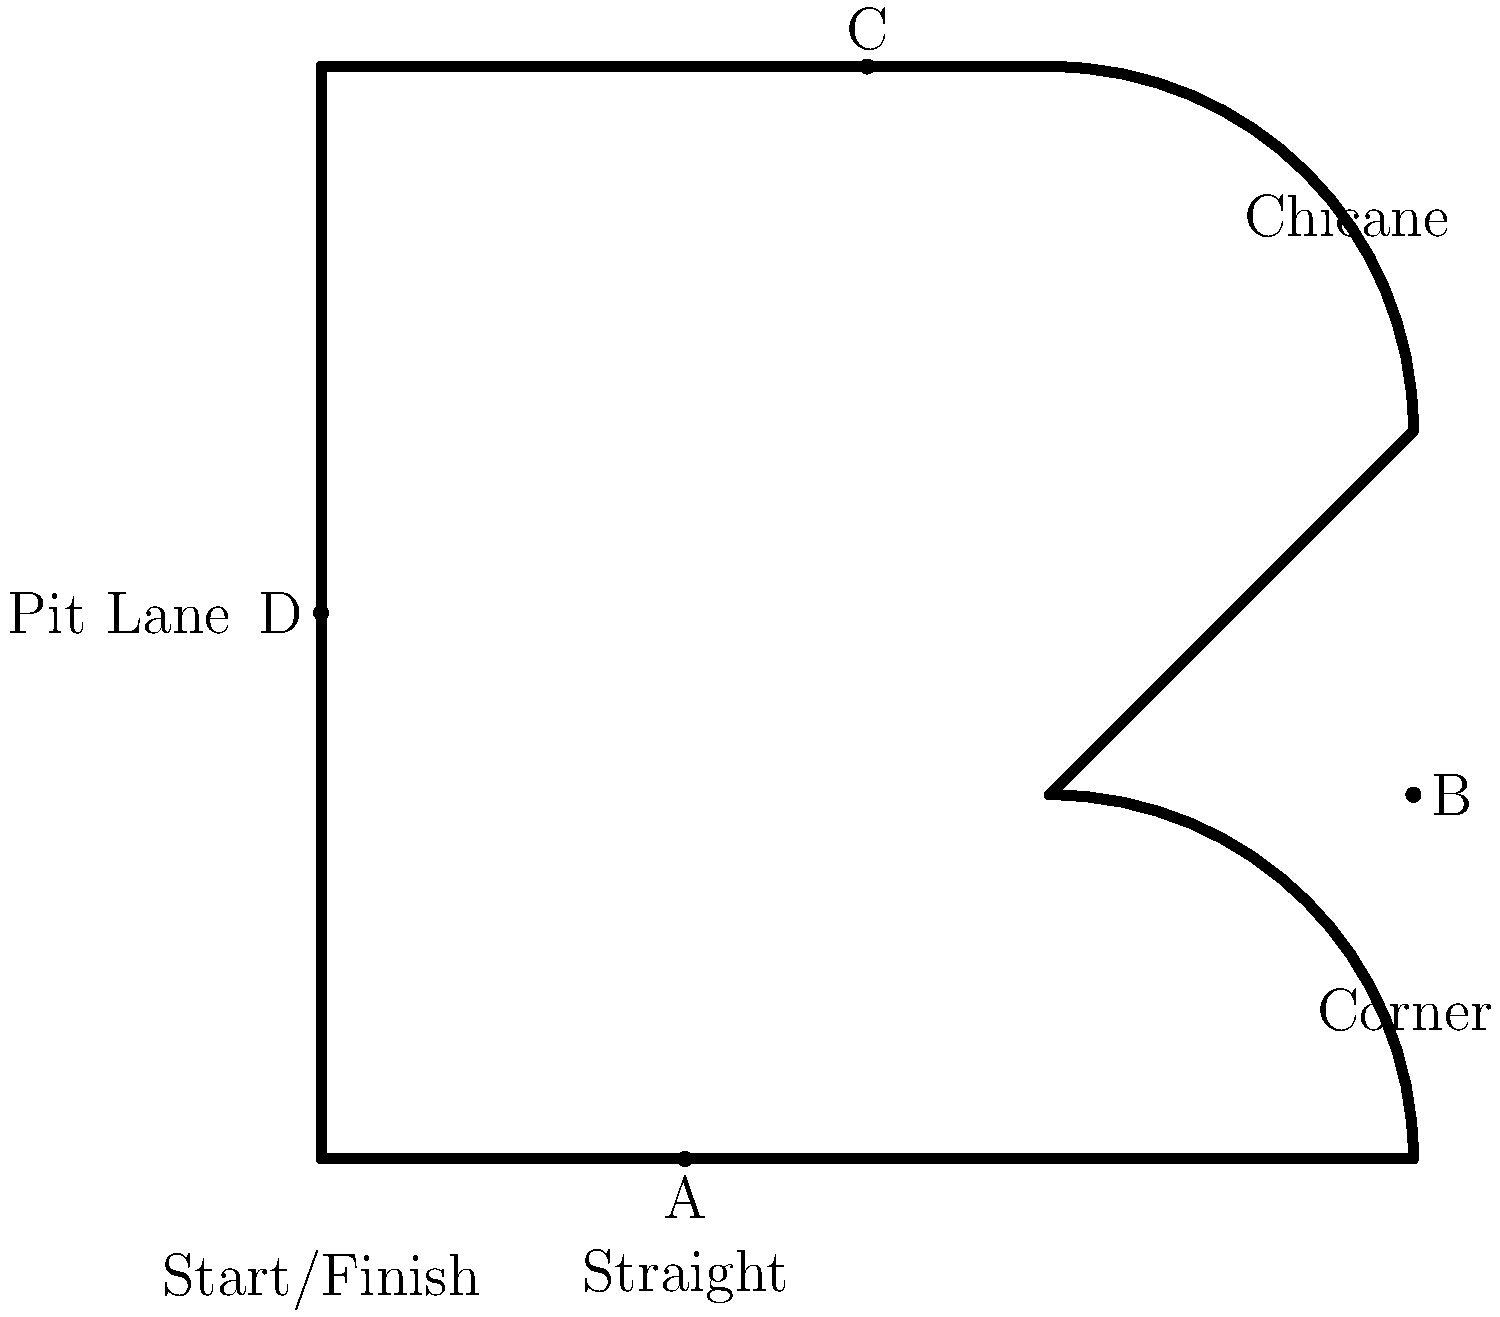Look at the race track layout above. What is the purpose of the feature labeled "B" on the track? To understand the purpose of feature B, let's break down the key elements of a race track:

1. The track layout shows various features common in motorsports circuits.

2. Feature B is located at a curved section of the track, following a straight section.

3. In racing, this type of curved section is called a corner or turn.

4. Corners serve several important purposes in racing:
   a) They test a driver's skill in controlling the car at different speeds and angles.
   b) They provide opportunities for overtaking other cars.
   c) They add variety and challenge to the track layout.

5. Corners like B require drivers to:
   a) Brake before entering the turn
   b) Choose the optimal racing line through the corner
   c) Accelerate out of the corner onto the next straight section

6. Mastering corners is crucial for achieving fast lap times and competitive racing.

Therefore, the purpose of feature B (a corner) is to challenge drivers, create overtaking opportunities, and add excitement to the race.
Answer: To challenge drivers and create overtaking opportunities 